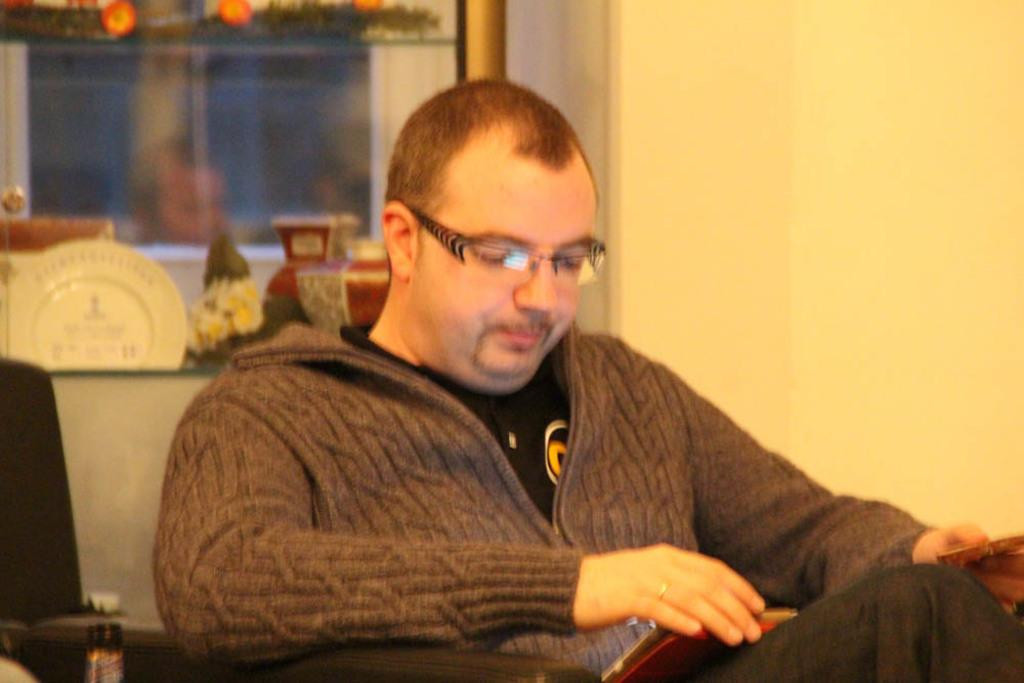What is the person in the image doing? The person is sitting in a chair and holding a book. What can be seen in the background of the image? There is a window and a wall visible in the background. What is on the table in the image? There is a plate and a flower pot on the table. What might the person be using to read the book? The person might be using a chair to sit and read the book. What type of pie is being baked in the oven in the image? There is no oven or pie present in the image. 